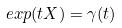<formula> <loc_0><loc_0><loc_500><loc_500>e x p ( t X ) = \gamma ( t )</formula> 